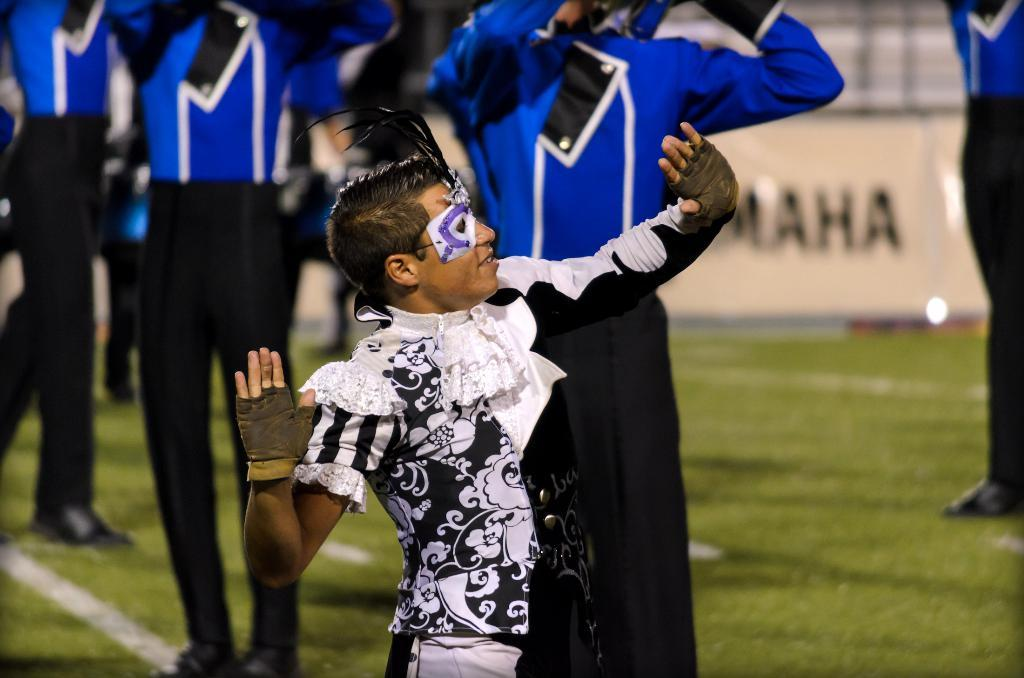Provide a one-sentence caption for the provided image. Omaha is a field sponsor during football season. 